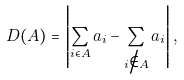<formula> <loc_0><loc_0><loc_500><loc_500>D ( A ) = \left | \sum _ { i \in A } a _ { i } - \sum _ { i \not \in A } a _ { i } \right | ,</formula> 